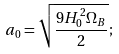<formula> <loc_0><loc_0><loc_500><loc_500>a _ { 0 } = \sqrt { \frac { 9 H _ { 0 } ^ { 2 } \Omega _ { B } } { 2 } } ;</formula> 